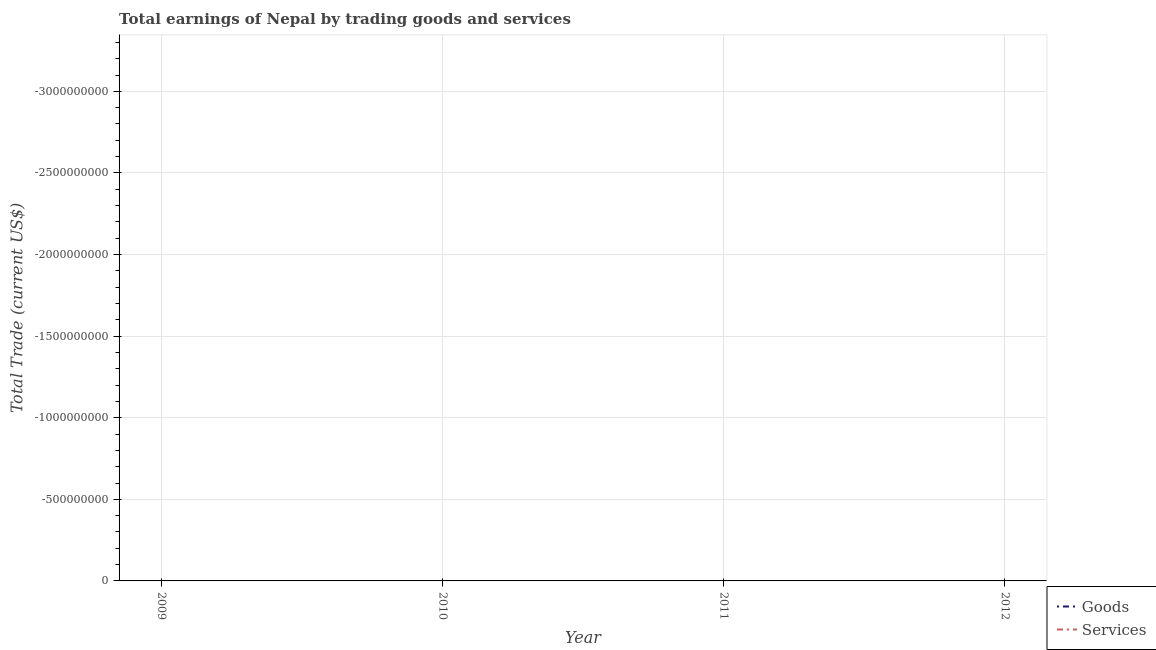How many different coloured lines are there?
Your answer should be very brief. 0. Is the number of lines equal to the number of legend labels?
Provide a succinct answer. No. What is the amount earned by trading services in 2010?
Offer a very short reply. 0. What is the total amount earned by trading services in the graph?
Ensure brevity in your answer.  0. In how many years, is the amount earned by trading goods greater than the average amount earned by trading goods taken over all years?
Offer a terse response. 0. Does the amount earned by trading services monotonically increase over the years?
Your answer should be compact. No. How many years are there in the graph?
Give a very brief answer. 4. Are the values on the major ticks of Y-axis written in scientific E-notation?
Offer a very short reply. No. How are the legend labels stacked?
Provide a short and direct response. Vertical. What is the title of the graph?
Ensure brevity in your answer.  Total earnings of Nepal by trading goods and services. What is the label or title of the X-axis?
Offer a very short reply. Year. What is the label or title of the Y-axis?
Provide a succinct answer. Total Trade (current US$). What is the Total Trade (current US$) in Services in 2009?
Offer a terse response. 0. What is the Total Trade (current US$) of Goods in 2010?
Your response must be concise. 0. What is the Total Trade (current US$) of Goods in 2011?
Your answer should be compact. 0. What is the total Total Trade (current US$) in Services in the graph?
Keep it short and to the point. 0. 